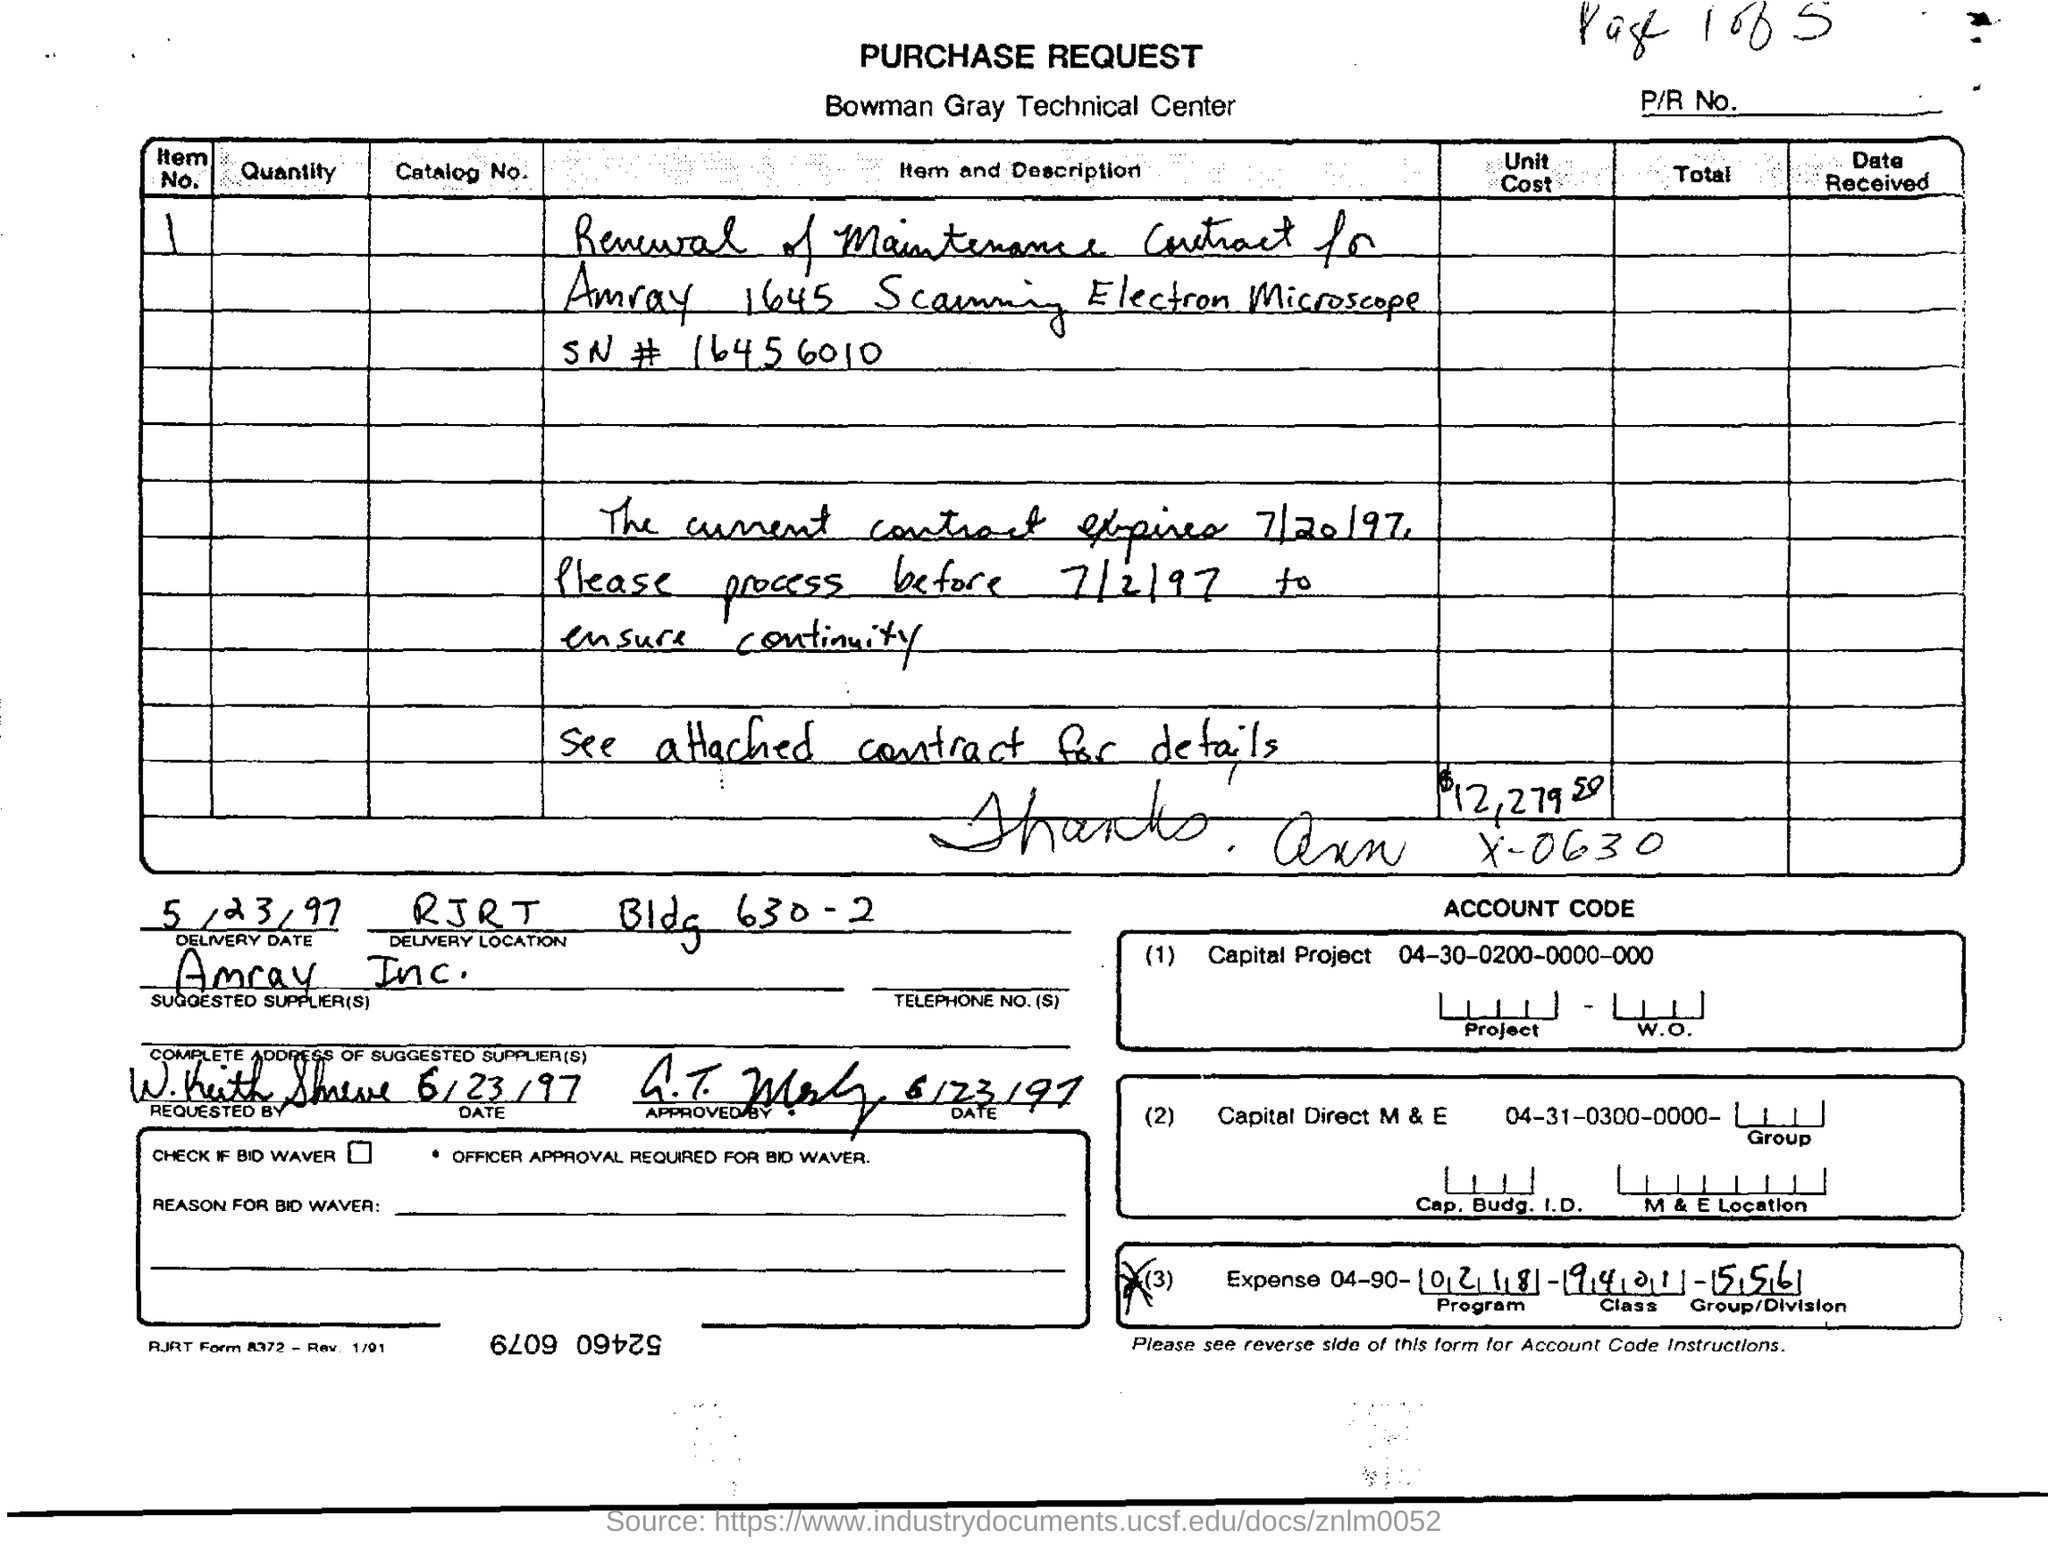Identify some key points in this picture. The delivery date is May 23, 1997. Bowman Gray Technical Center is the name of the technical center. 